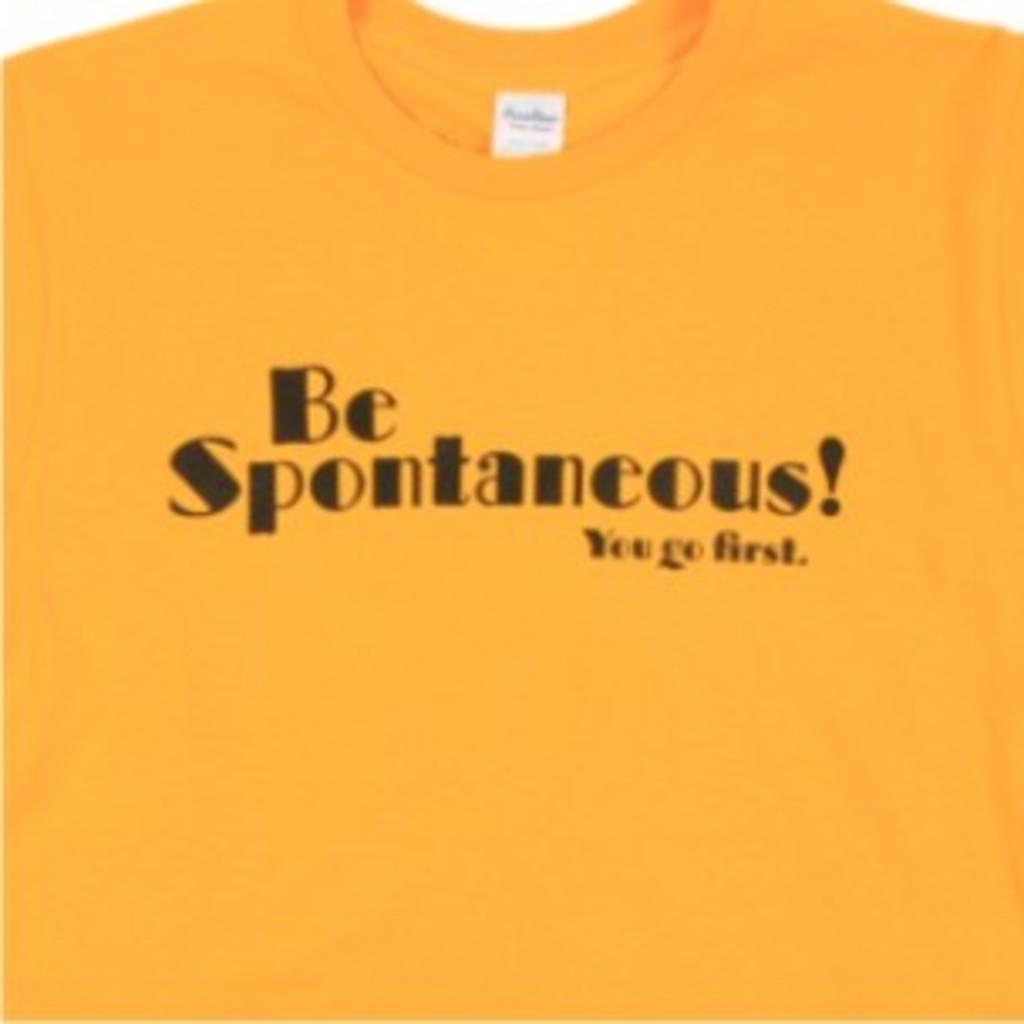How would you summarize this image in a sentence or two? In the foreground of this picture, there is a yellow T shirt on which " BE SPONTANEOUS! YOU GO FIRST" is written on it. 